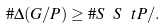<formula> <loc_0><loc_0><loc_500><loc_500>\# \Delta ( G / P ) \geq \# S \ S ^ { \ } t P / .</formula> 